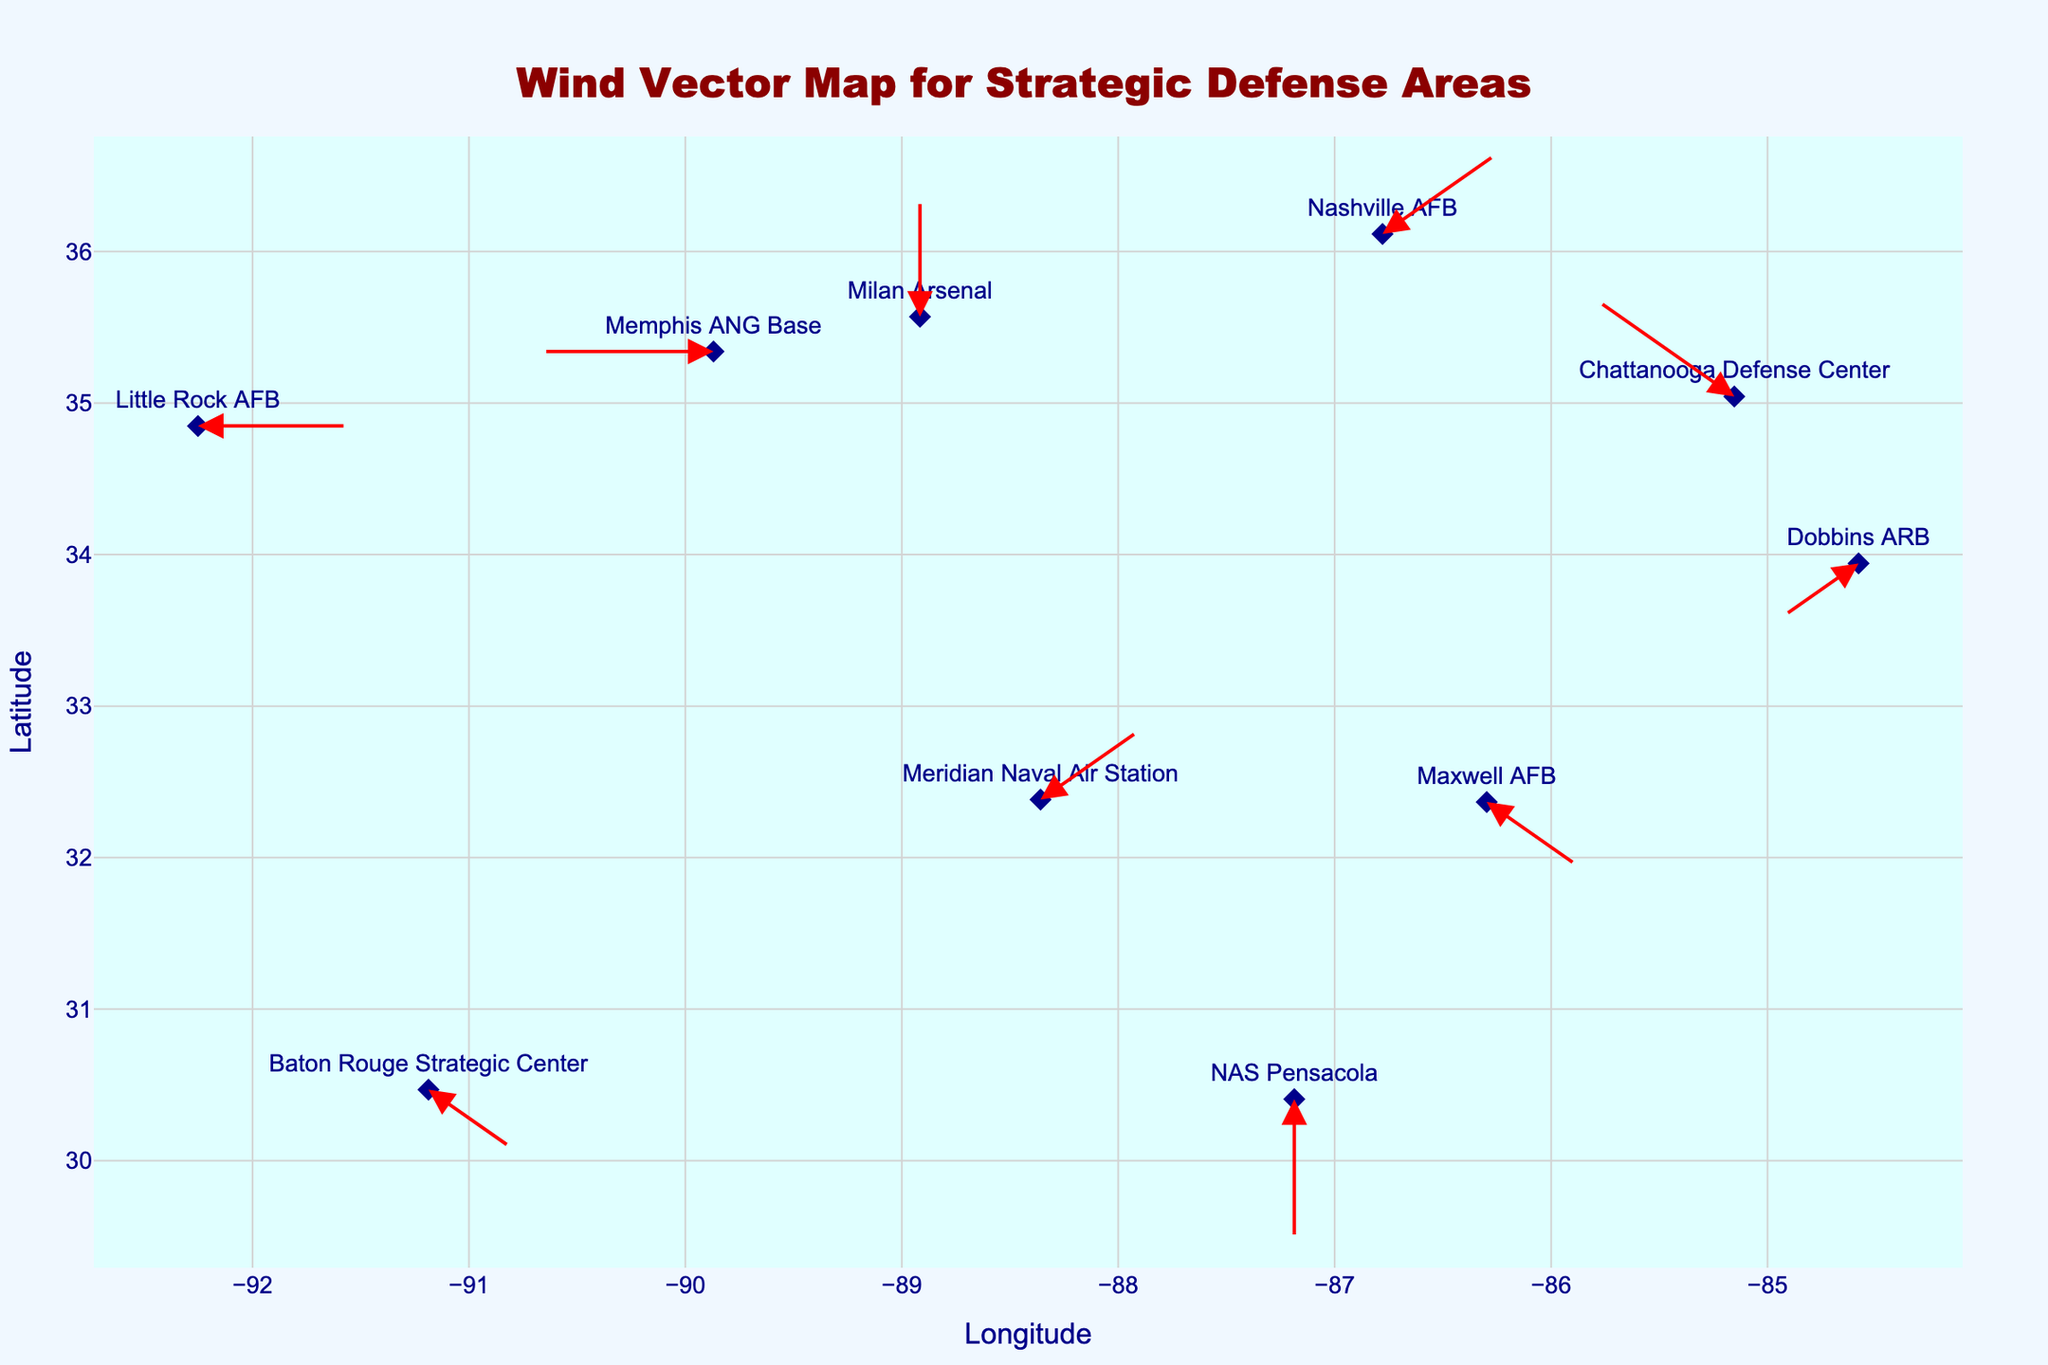What is the wind direction and speed at Memphis ANG Base? Look at the map, find Memphis ANG Base labeled as one of the locations, identify the wind arrow and hover text associated with it. The hover text indicates "W 16 knots".
Answer: W, 16 knots Which location has the highest wind speed? Examine the hover texts on the figure for each location to find which one has the highest wind speed. NAS Pensacola shows "S 20 knots", which is the highest speed.
Answer: NAS Pensacola What is the average wind speed across all locations? Sum the wind speeds of all locations (15 + 12 + 18 + 10 + 14 + 20 + 16 + 13 + 11 + 17) = 146 knots, then divide by the number of locations (10). The average wind speed is 146/10 = 14.6 knots.
Answer: 14.6 knots Which locations have easterly wind components (E, NE, SE)? Identify the locations with wind directions E, NE, and SE: Nashville AFB (NE), Maxwell AFB (SE), Little Rock AFB (E), Meridian NAS (NE), and Baton Rouge Strategic Center (SE).
Answer: Nashville AFB, Maxwell AFB, Little Rock AFB, Meridian NAS, Baton Rouge Strategic Center What is the overall wind direction at Chattanooga Defense Center? Find Chattanooga Defense Center on the map and look at the associated wind arrow and hover text. It indicates "NW 18 knots".
Answer: NW Which location closest to the 36 degrees latitude line? Look at the y-axis (latitude) and find the location closest to 36 degrees. Nashville AFB at latitude 36.1162 is the closest.
Answer: Nashville AFB Compare wind directions between Nashville AFB and Dobbins ARB. Which one has a more northerly component? Nashville AFB has NE wind, and Dobbins ARB has SW wind. NE (North-East) has more northerly component than SW (South-West).
Answer: Nashville AFB Identify the location with the southernmost latitude. What is its wind direction and speed? Find the location with the smallest latitude value, which is NAS Pensacola at 30.4058. The hover text for NAS Pensacola indicates "S 20 knots".
Answer: NAS Pensacola, S, 20 knots 